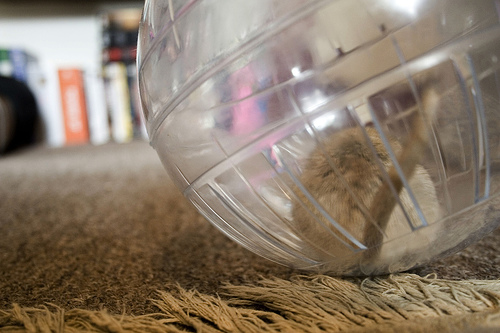<image>
Is the gerbil in the ball? Yes. The gerbil is contained within or inside the ball, showing a containment relationship. Where is the hampster in relation to the ball? Is it in front of the ball? No. The hampster is not in front of the ball. The spatial positioning shows a different relationship between these objects. 